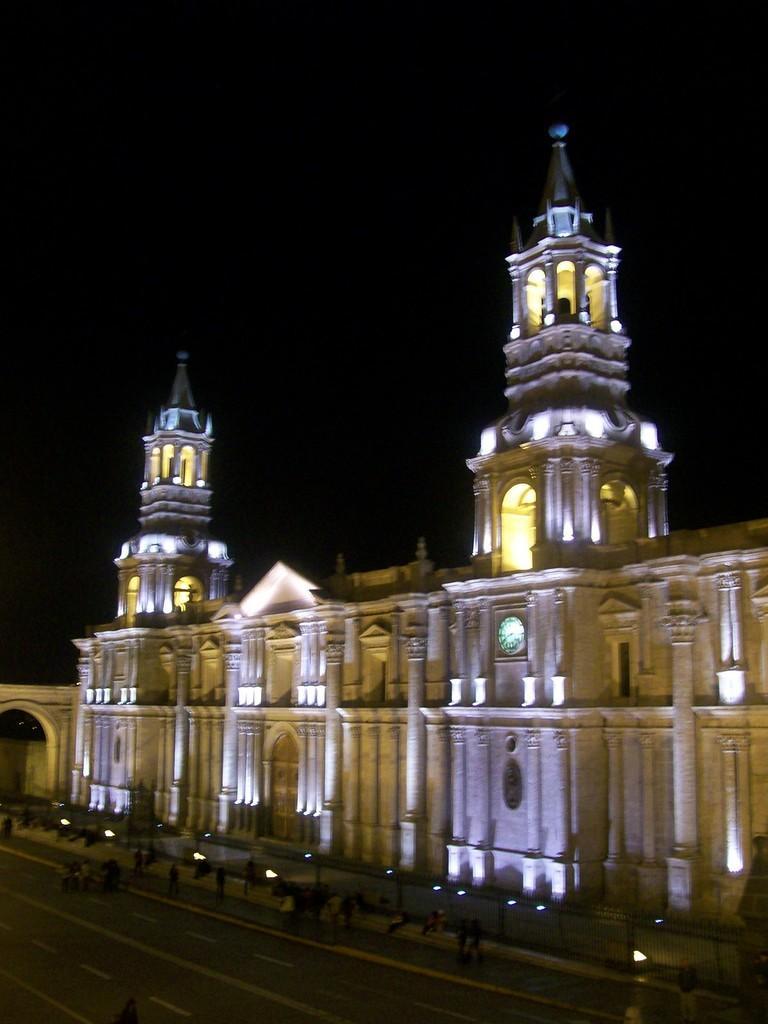Please provide a concise description of this image. In this image in the background there is a castle and persons in front of the castle. 